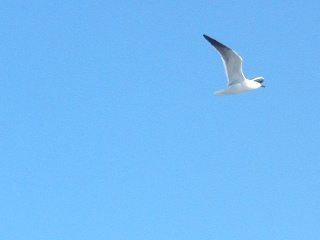Imagine if the bird in the image had a tiny camera attached to it. What could be some interesting views it might capture on its flight? If the bird had a tiny camera attached, it would capture sweeping views of the ocean's vast expanse, glimpses of ships navigating the waters, coastal cliffs, and perhaps even schools of fish swimming near the surface. From above, the dynamic scenery would include other birds, scenic beaches, quaint seaside townscapes, and expansive coastal forests. The bird might also capture stunning sunsets, with rich hues unfolding across the sky as the sun dips below the horizon. 